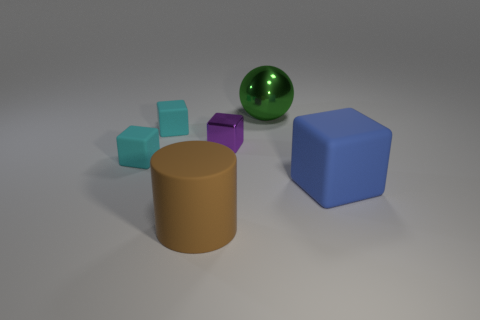How are the colors of the objects distributed in the scene? The scene is a festival of hues, with colors placed in a compelling yet unstructured array. The cool teal of the smallest cubes contrasts elegantly with the deep purple and soft lilac of their brethren, while the green of the ball provides a singular burst of vibrancy. The solitary blue cube and brown cylinder anchor the assembly with their solid, uncluttered tones. What can you infer about the lighting of the scene? The lighting seems to come from above, given the placement of the soft shadows that ground each object. The diffused quality of the light envelops the scene in a tranquil ambience, highlighting the contours of the shapes without creating harsh contrasts. 